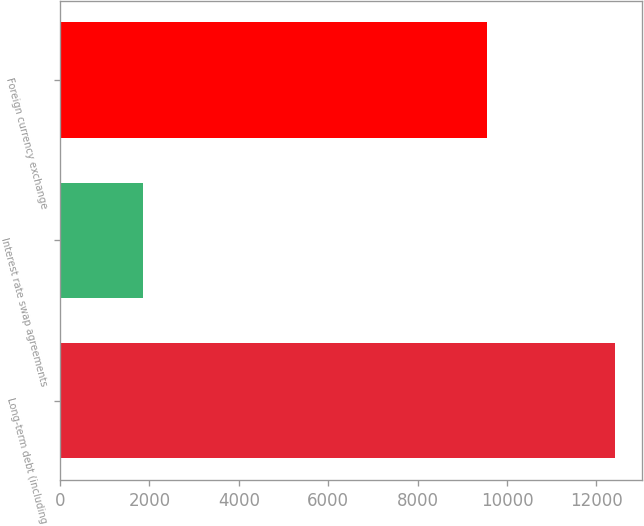<chart> <loc_0><loc_0><loc_500><loc_500><bar_chart><fcel>Long-term debt (including<fcel>Interest rate swap agreements<fcel>Foreign currency exchange<nl><fcel>12409<fcel>1850<fcel>9554<nl></chart> 